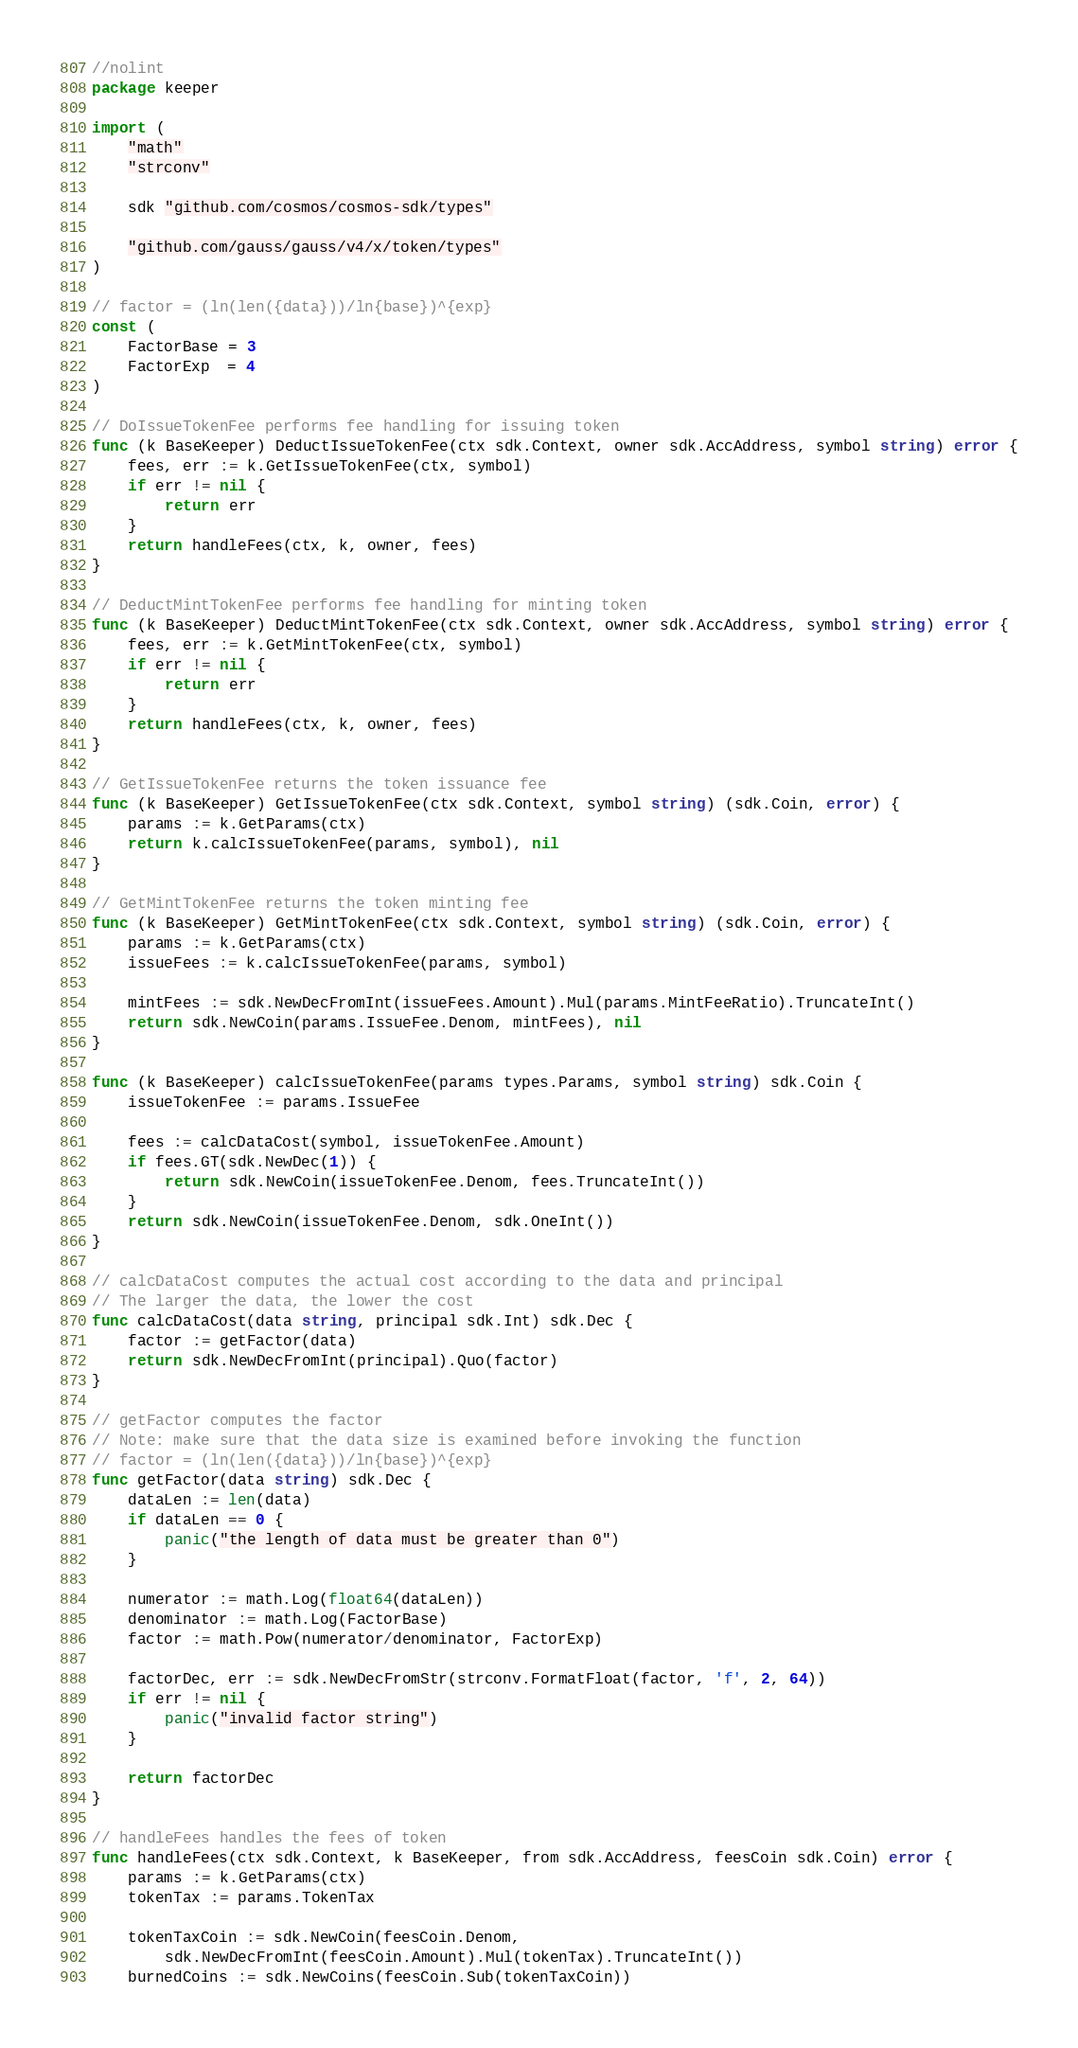Convert code to text. <code><loc_0><loc_0><loc_500><loc_500><_Go_>//nolint
package keeper

import (
	"math"
	"strconv"

	sdk "github.com/cosmos/cosmos-sdk/types"

	"github.com/gauss/gauss/v4/x/token/types"
)

// factor = (ln(len({data}))/ln{base})^{exp}
const (
	FactorBase = 3
	FactorExp  = 4
)

// DoIssueTokenFee performs fee handling for issuing token
func (k BaseKeeper) DeductIssueTokenFee(ctx sdk.Context, owner sdk.AccAddress, symbol string) error {
	fees, err := k.GetIssueTokenFee(ctx, symbol)
	if err != nil {
		return err
	}
	return handleFees(ctx, k, owner, fees)
}

// DeductMintTokenFee performs fee handling for minting token
func (k BaseKeeper) DeductMintTokenFee(ctx sdk.Context, owner sdk.AccAddress, symbol string) error {
	fees, err := k.GetMintTokenFee(ctx, symbol)
	if err != nil {
		return err
	}
	return handleFees(ctx, k, owner, fees)
}

// GetIssueTokenFee returns the token issuance fee
func (k BaseKeeper) GetIssueTokenFee(ctx sdk.Context, symbol string) (sdk.Coin, error) {
	params := k.GetParams(ctx)
	return k.calcIssueTokenFee(params, symbol), nil
}

// GetMintTokenFee returns the token minting fee
func (k BaseKeeper) GetMintTokenFee(ctx sdk.Context, symbol string) (sdk.Coin, error) {
	params := k.GetParams(ctx)
	issueFees := k.calcIssueTokenFee(params, symbol)

	mintFees := sdk.NewDecFromInt(issueFees.Amount).Mul(params.MintFeeRatio).TruncateInt()
	return sdk.NewCoin(params.IssueFee.Denom, mintFees), nil
}

func (k BaseKeeper) calcIssueTokenFee(params types.Params, symbol string) sdk.Coin {
	issueTokenFee := params.IssueFee

	fees := calcDataCost(symbol, issueTokenFee.Amount)
	if fees.GT(sdk.NewDec(1)) {
		return sdk.NewCoin(issueTokenFee.Denom, fees.TruncateInt())
	}
	return sdk.NewCoin(issueTokenFee.Denom, sdk.OneInt())
}

// calcDataCost computes the actual cost according to the data and principal
// The larger the data, the lower the cost
func calcDataCost(data string, principal sdk.Int) sdk.Dec {
	factor := getFactor(data)
	return sdk.NewDecFromInt(principal).Quo(factor)
}

// getFactor computes the factor
// Note: make sure that the data size is examined before invoking the function
// factor = (ln(len({data}))/ln{base})^{exp}
func getFactor(data string) sdk.Dec {
	dataLen := len(data)
	if dataLen == 0 {
		panic("the length of data must be greater than 0")
	}

	numerator := math.Log(float64(dataLen))
	denominator := math.Log(FactorBase)
	factor := math.Pow(numerator/denominator, FactorExp)

	factorDec, err := sdk.NewDecFromStr(strconv.FormatFloat(factor, 'f', 2, 64))
	if err != nil {
		panic("invalid factor string")
	}

	return factorDec
}

// handleFees handles the fees of token
func handleFees(ctx sdk.Context, k BaseKeeper, from sdk.AccAddress, feesCoin sdk.Coin) error {
	params := k.GetParams(ctx)
	tokenTax := params.TokenTax

	tokenTaxCoin := sdk.NewCoin(feesCoin.Denom,
		sdk.NewDecFromInt(feesCoin.Amount).Mul(tokenTax).TruncateInt())
	burnedCoins := sdk.NewCoins(feesCoin.Sub(tokenTaxCoin))
</code> 